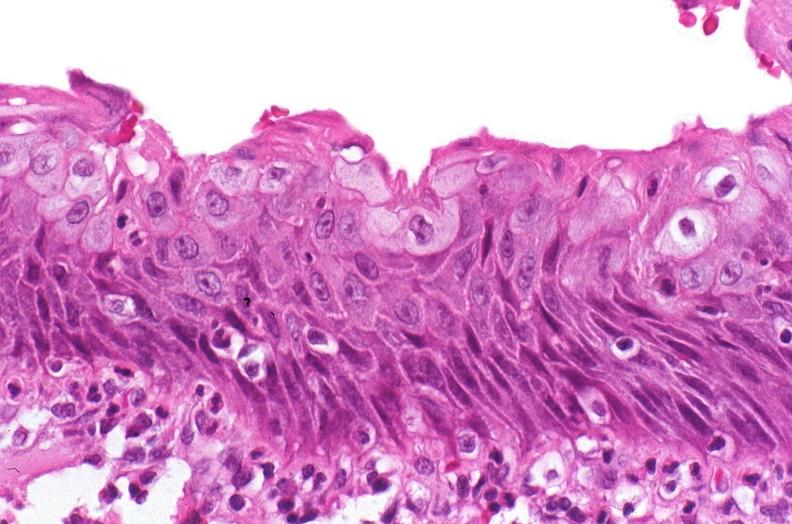what does this image show?
Answer the question using a single word or phrase. Renal pelvis 